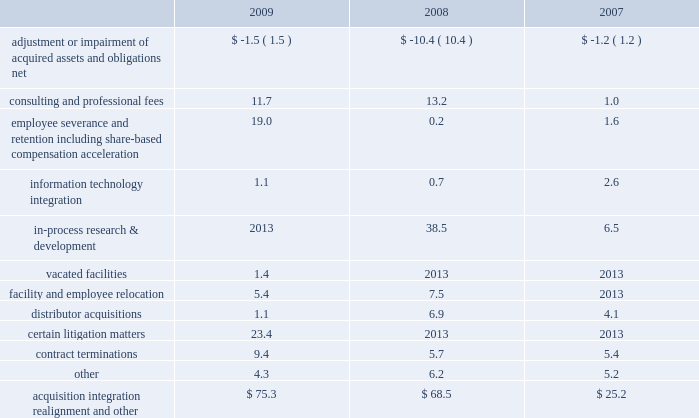Realignment and other 201d expenses .
Acquisition , integration , realignment and other expenses for the years ended december 31 , 2009 , 2008 and 2007 , included ( in millions ) : .
Adjustment or impairment of acquired assets and obligations relates to impairment on assets that were acquired in business combinations or adjustments to certain liabilities of acquired companies due to changes in circumstances surrounding those liabilities subsequent to the related measurement period .
Consulting and professional fees relate to third-party integration consulting performed in a variety of areas such as tax , compliance , logistics and human resources and include third-party fees related to severance and termination benefits matters .
These fees also include legal fees related to litigation matters involving acquired businesses that existed prior to our acquisition or resulted from our acquisition .
During 2009 , we commenced a global realignment initiative to focus on business opportunities that best support our strategic priorities .
As part of this realignment , we initiated changes in our work force , eliminating positions in some areas and increasing others .
Approximately 300 employees from across the globe were affected by these actions .
As a result of these changes in our work force and headcount reductions from acquisitions , we recorded expense of $ 19.0 million related to severance and other employee termination-related costs .
These termination benefits were provided in accordance with our existing or local government policies and are considered ongoing benefits .
These costs were accrued when they became probable and estimable and were recorded as part of other current liabilities .
The majority of these costs were paid during 2009 .
Information technology integration relates to the non- capitalizable costs associated with integrating the information systems of acquired businesses .
In-process research and development charges for 2008 relate to the acquisition of abbott spine .
In-process research and development charges for 2007 relate to the acquisitions of endius and orthosoft .
In 2009 , we ceased using certain leased facilities and , accordingly , recorded expense for the remaining lease payments , less estimated sublease recoveries , and wrote-off any assets being used in those facilities .
Facility and employee relocation relates to costs associated with relocating certain facilities .
Most notably , we consolidated our legacy european distribution centers into a new distribution center in eschbach , germany .
Over the past three years we have acquired a number of u.s .
And foreign-based distributors .
We have incurred various costs related to the acquisition and integration of those businesses .
Certain litigation matters relate to costs recognized during the year for the estimated or actual settlement of various legal matters , including patent litigation matters , commercial litigation matters and matters arising from our acquisitions of certain competitive distributorships in prior years .
We recognize expense for the potential settlement of a legal matter when we believe it is probable that a loss has been incurred and we can reasonably estimate the loss .
In 2009 , we made a concerted effort to settle many of these matters to avoid further litigation costs .
Contract termination costs relate to terminated agreements in connection with the integration of acquired companies .
The terminated contracts primarily relate to sales agents and distribution agreements .
Cash and cash equivalents 2013 we consider all highly liquid investments with an original maturity of three months or less to be cash equivalents .
The carrying amounts reported in the balance sheet for cash and cash equivalents are valued at cost , which approximates their fair value .
Certificates of deposit 2013 we invest in cash deposits with original maturities greater than three months and classify these investments as certificates of deposit on our consolidated balance sheet .
The carrying amounts reported in the balance sheet for certificates of deposit are valued at cost , which approximates their fair value .
Inventories 2013 inventories , net of allowances for obsolete and slow-moving goods , are stated at the lower of cost or market , with cost determined on a first-in first-out basis .
Property , plant and equipment 2013 property , plant and equipment is carried at cost less accumulated depreciation .
Depreciation is computed using the straight-line method based on estimated useful lives of ten to forty years for buildings and improvements and three to eight years for machinery and equipment .
Maintenance and repairs are expensed as incurred .
We review property , plant and equipment for impairment whenever events or changes in circumstances indicate that the carrying value of an asset may not be recoverable .
An impairment loss would be recognized when estimated future undiscounted cash flows relating to the asset are less than its carrying amount .
An impairment loss is measured as the amount by which the carrying amount of an asset exceeds its fair value .
Z i m m e r h o l d i n g s , i n c .
2 0 0 9 f o r m 1 0 - k a n n u a l r e p o r t notes to consolidated financial statements ( continued ) %%transmsg*** transmitting job : c55340 pcn : 043000000 ***%%pcmsg|43 |00008|yes|no|02/24/2010 01:32|0|0|page is valid , no graphics -- color : d| .
What is the expense related to severance and other employee termination-related costs as a percentage of the acquisition integration realignment and other expenses in 2009? 
Computations: (19.0 / 75.3)
Answer: 0.25232. 